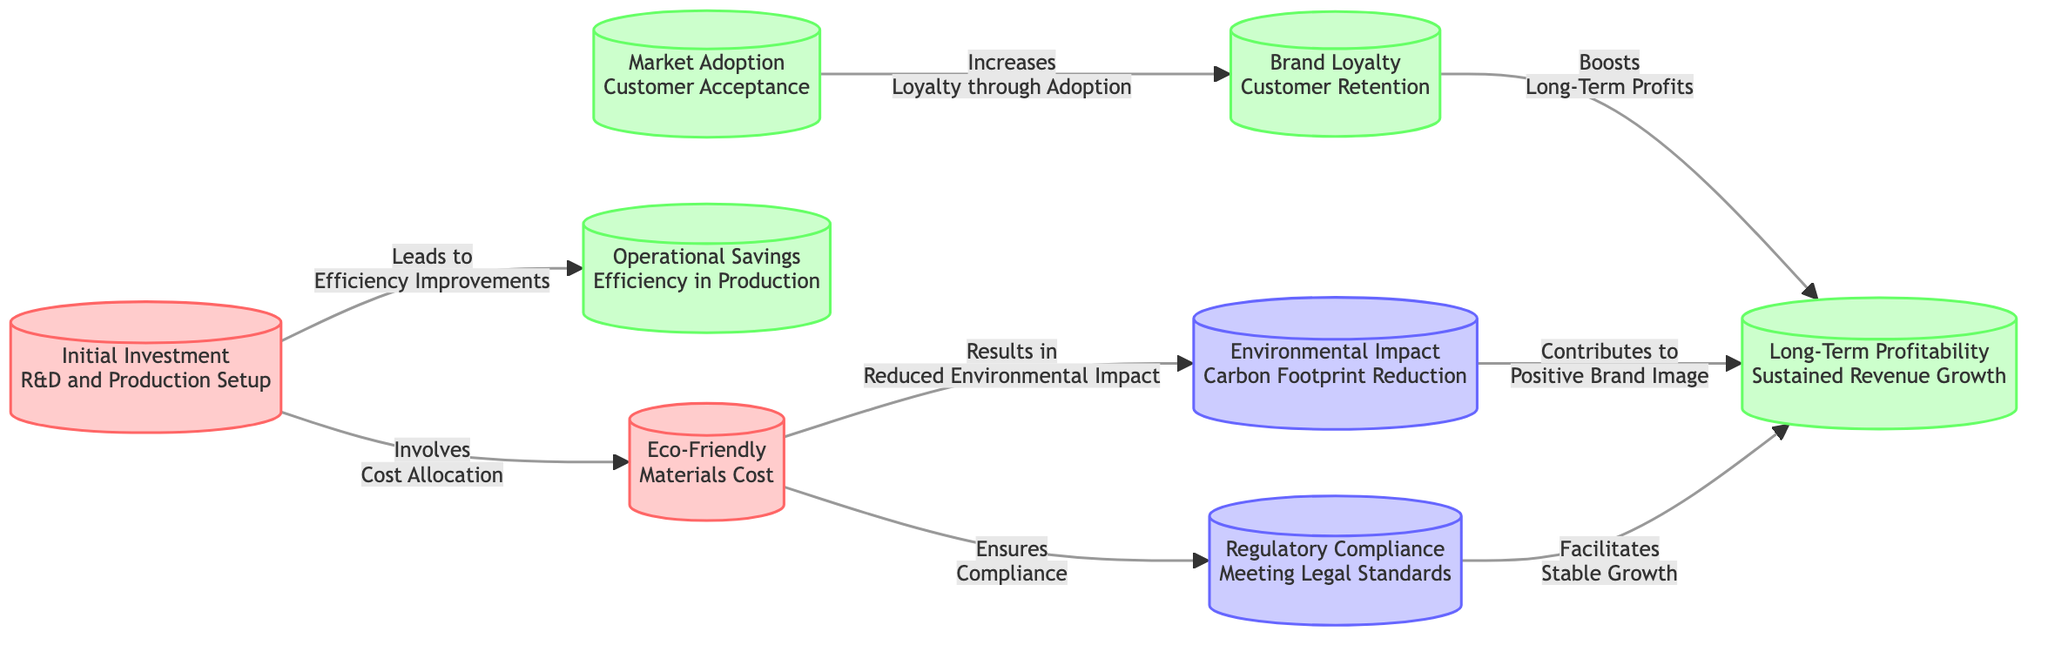What is the initial investment related to? The initial investment refers to R&D and production setup, as indicated in the first node labeled "Initial Investment".
Answer: R&D and Production Setup How many benefits are mentioned in the diagram? The diagram lists five benefits: Operational Savings, Market Adoption, Brand Loyalty, Long-Term Profitability, and Customer Retention. Count these nodes to arrive at the total.
Answer: 5 Which node is linked to "Reduced Environmental Impact"? The node that is linked to "Reduced Environmental Impact" is "Eco-Friendly Materials Cost", as shown in the connection that describes the outcome of using eco-friendly materials.
Answer: Eco-Friendly Materials Cost What improves efficiency according to the diagram? "Initial Investment" is linked to "Efficiency Improvements", indicating that it leads to improvements in production efficiency.
Answer: Efficiency Improvements Which two nodes facilitate stable growth? The nodes that facilitate stable growth are "Regulatory Compliance" and "Reduced Environmental Impact" because they are both linked to "Long-Term Profitability", which in turn contributes to stable growth.
Answer: Regulatory Compliance and Reduced Environmental Impact What contributes to a positive brand image? "Environmental Impact" node, specifically the "Carbon Footprint Reduction", contributes to the overall positive brand image, as stated in the diagram.
Answer: Carbon Footprint Reduction How does "Market Adoption" affect customer loyalty? "Market Adoption" leads to "Increased Loyalty through Adoption", establishing a relationship where adoption enhances customer loyalty.
Answer: Increased Loyalty through Adoption What is the relationship between "Brand Loyalty" and "Long-Term Profitability"? "Brand Loyalty" boosts "Long-Term Profits" as depicted in the diagram, indicating a direct benefit relationship between these two nodes.
Answer: Boosts Long-Term Profits How many edges connect "Initial Investment" to other nodes? The "Initial Investment" node contains two outgoing edges connecting to both "Efficiency Improvements" and "Eco-Friendly Materials Cost", indicating two pathways leading from this node.
Answer: 2 